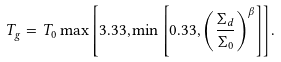<formula> <loc_0><loc_0><loc_500><loc_500>T _ { g } = T _ { 0 } \max { \left [ 3 . 3 3 , \min { \left [ 0 . 3 3 , \left ( \frac { \Sigma _ { d } } { \Sigma _ { 0 } } \right ) ^ { \beta } \right ] } \right ] } .</formula> 